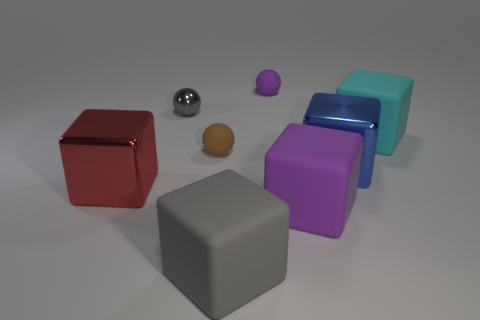There is a big object that is the same color as the tiny metallic thing; what is its material?
Provide a short and direct response. Rubber. There is a brown rubber thing; does it have the same shape as the purple rubber object that is behind the large red block?
Your answer should be compact. Yes. What number of objects are either big purple rubber objects or matte blocks that are left of the large blue thing?
Offer a terse response. 2. What material is the red thing that is the same shape as the cyan object?
Give a very brief answer. Metal. Is the shape of the metal thing on the right side of the tiny purple rubber object the same as  the cyan rubber thing?
Ensure brevity in your answer.  Yes. Are there fewer large matte things that are behind the big blue cube than small gray objects that are on the right side of the small brown object?
Make the answer very short. No. How many other objects are there of the same shape as the big blue metal object?
Provide a succinct answer. 4. There is a metallic cube that is left of the tiny matte thing that is left of the matte ball behind the cyan object; what is its size?
Your answer should be very brief. Large. What number of green objects are shiny balls or small rubber cubes?
Your answer should be compact. 0. What shape is the small rubber thing left of the tiny matte object that is behind the cyan rubber block?
Offer a terse response. Sphere. 